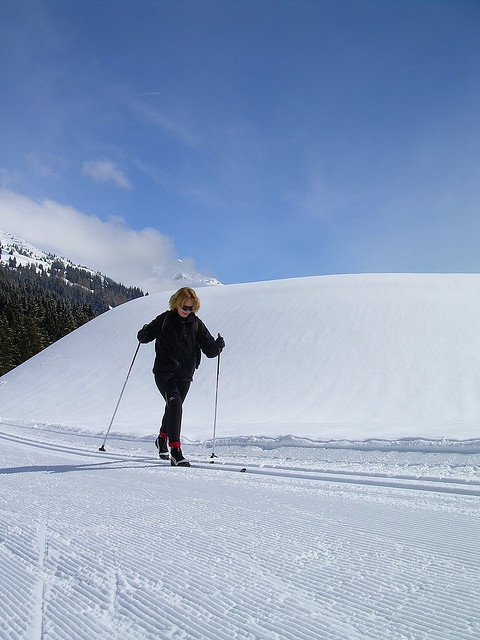Describe the objects in this image and their specific colors. I can see people in blue, black, lavender, gray, and maroon tones and skis in blue, black, gray, darkgray, and lightgray tones in this image. 